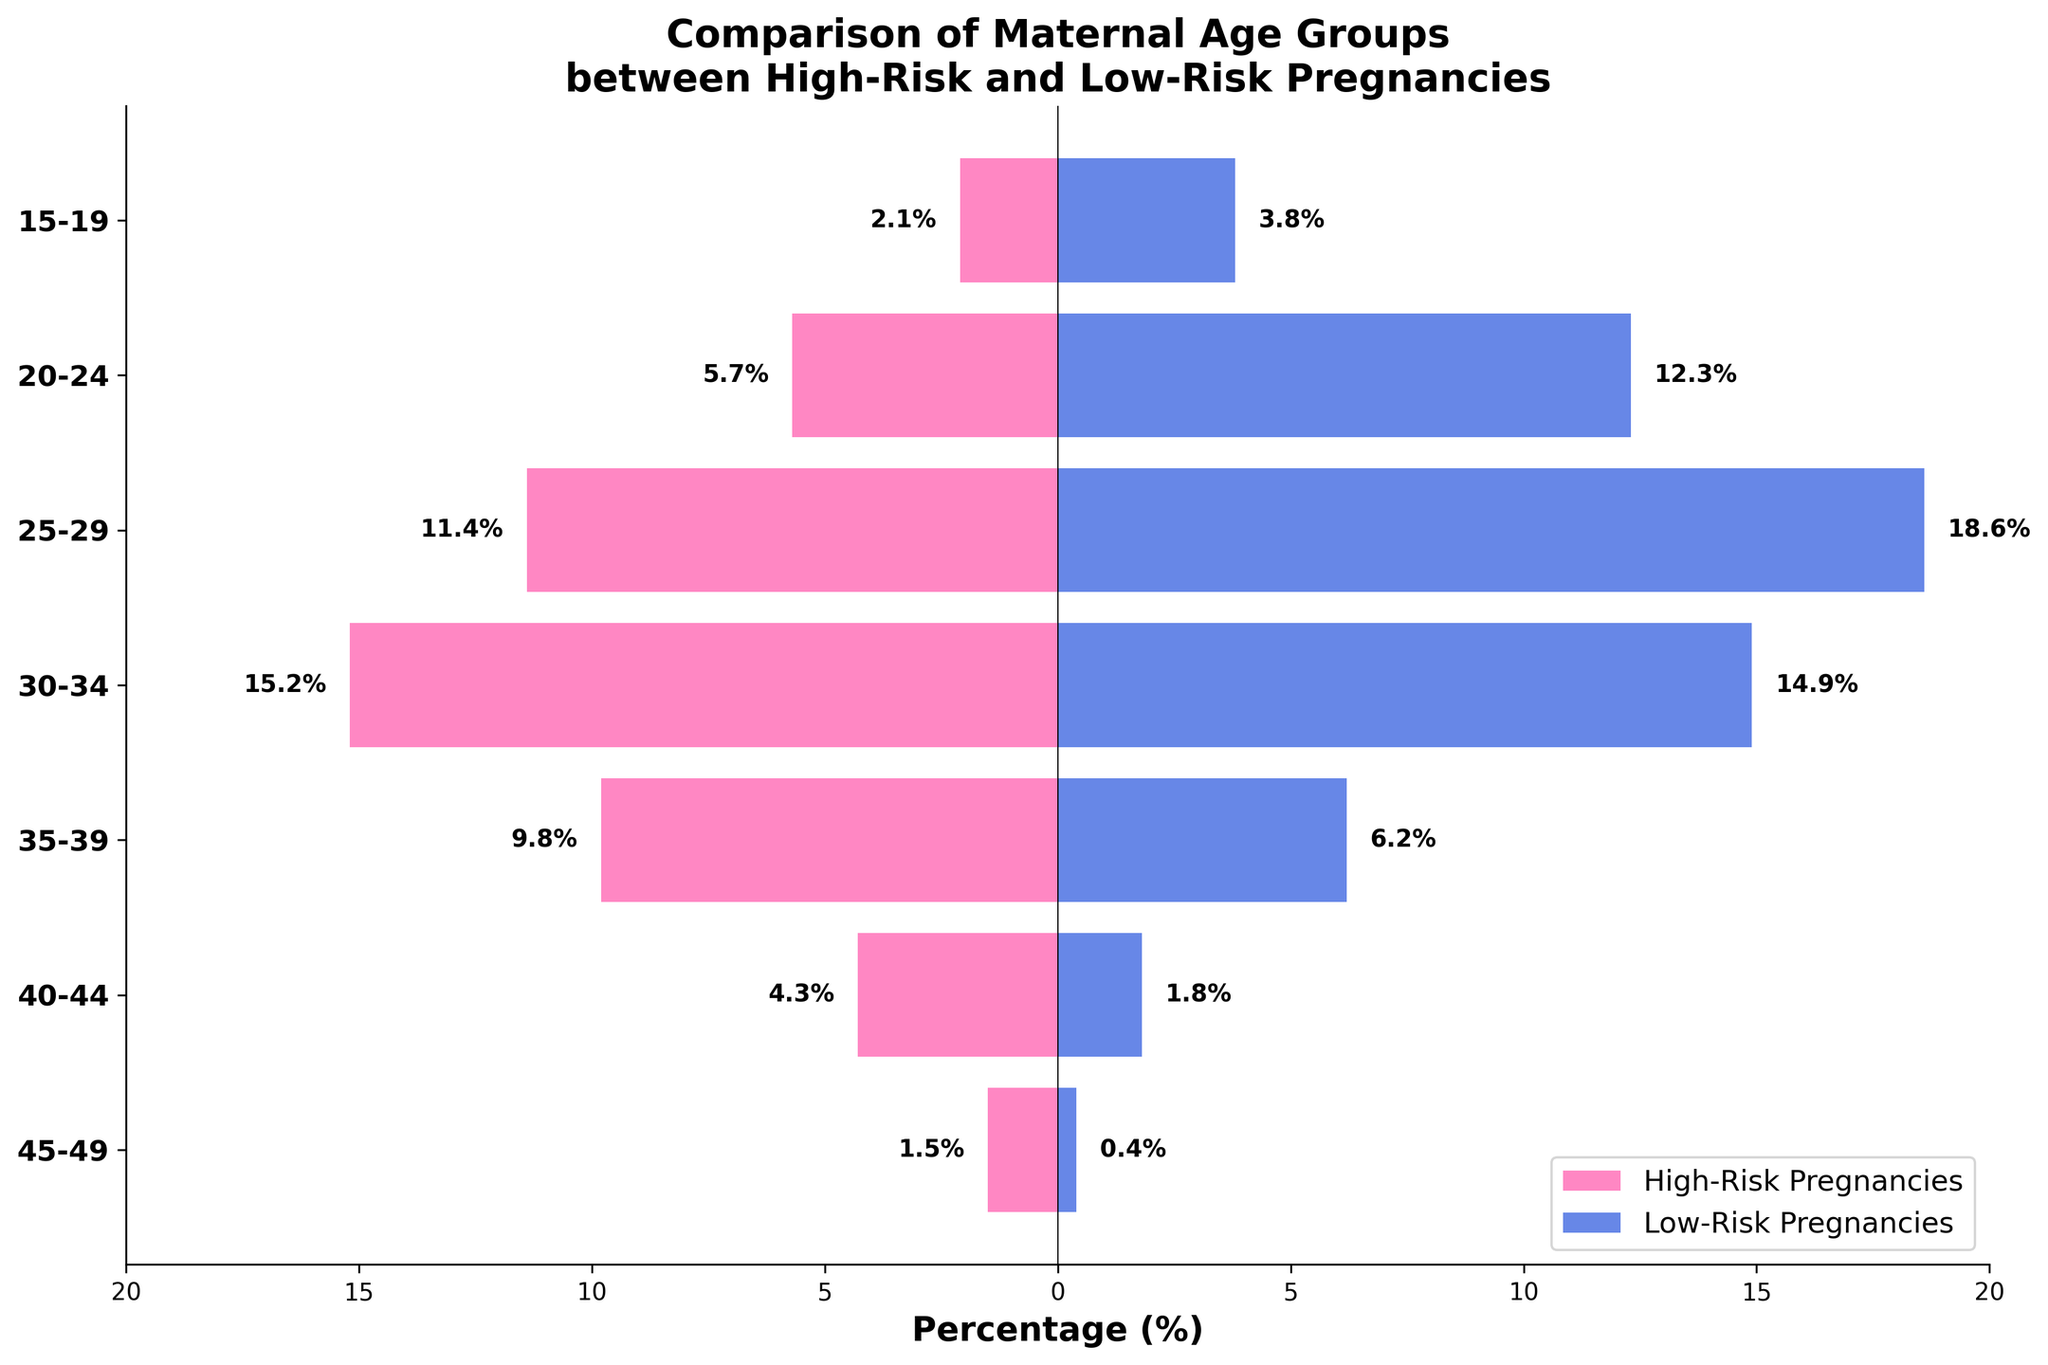What's the title of the plot? The title is displayed at the top of the figure and reads "Comparison of Maternal Age Groups between High-Risk and Low-Risk Pregnancies".
Answer: Comparison of Maternal Age Groups between High-Risk and Low-Risk Pregnancies What color represents high-risk pregnancies? High-risk pregnancies are shown using the bars colored in pink.
Answer: Pink How are the age groups (15-19) represented in terms of high-risk and low-risk percentages? The figure shows high-risk pregnancies as 2.1% and low-risk pregnancies as 3.8% for the age group 15-19.
Answer: 2.1% for high-risk and 3.8% for low-risk Which age group has the highest percentage of high-risk pregnancies? By examining the length of the bars, the age group 30-34 displays the highest percentage of high-risk pregnancies at 15.2%.
Answer: 30-34 What is the difference in low-risk pregnancy percentages between age groups 20-24 and 40-44? To find the difference, subtract the percentage of low-risk pregnancies in the 40-44 from the 20-24. So, 12.3% - 1.8% = 10.5%.
Answer: 10.5% Which age group shifts from having fewer low-risk pregnancies to having more high-risk pregnancies? The age group 30-34 is the point where low-risk pregnancies decrease compared to high-risk. It shows 15.2% high-risk and 14.9% low-risk pregnancies.
Answer: 30-34 Is there an age group where the percentage of low-risk pregnancies is higher than the percentage of high-risk pregnancies by more than 10%? By comparing each age group's percentages, the group 25-29 shows the largest difference. Low-risk pregnancies are 18.6% compared to 11.4% high-risk pregnancies, a difference of 7.2%, which is not more than 10%. Hence, no group has such a difference.
Answer: No Between the age groups 35-39 and 45-49, which group has a higher percentage of high-risk pregnancies? By examining the lengths of the bars in these age groups, 35-39 has 9.8% high-risk pregnancies compared to 45-49 with 1.5%.
Answer: 35-39 